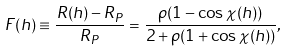Convert formula to latex. <formula><loc_0><loc_0><loc_500><loc_500>F ( h ) \equiv \frac { R ( h ) - R _ { P } } { R _ { P } } = \frac { \rho ( 1 - \cos \chi ( h ) ) } { 2 + \rho ( 1 + \cos \chi ( h ) ) } ,</formula> 